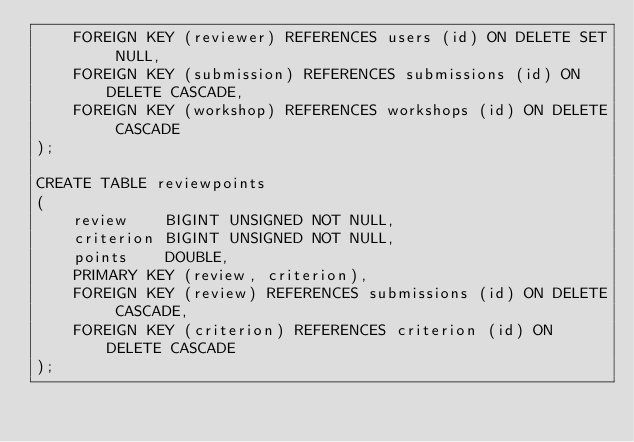Convert code to text. <code><loc_0><loc_0><loc_500><loc_500><_SQL_>    FOREIGN KEY (reviewer) REFERENCES users (id) ON DELETE SET NULL,
    FOREIGN KEY (submission) REFERENCES submissions (id) ON DELETE CASCADE,
    FOREIGN KEY (workshop) REFERENCES workshops (id) ON DELETE CASCADE
);

CREATE TABLE reviewpoints
(
    review    BIGINT UNSIGNED NOT NULL,
    criterion BIGINT UNSIGNED NOT NULL,
    points    DOUBLE,
    PRIMARY KEY (review, criterion),
    FOREIGN KEY (review) REFERENCES submissions (id) ON DELETE CASCADE,
    FOREIGN KEY (criterion) REFERENCES criterion (id) ON DELETE CASCADE
);</code> 